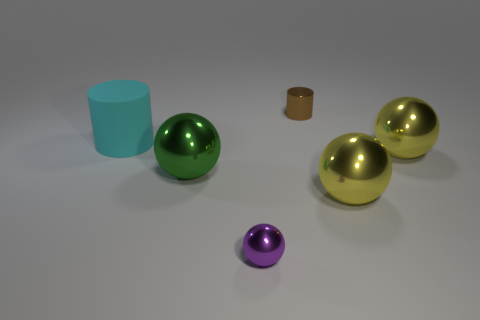Which object appears to be the largest? The largest object in the image appears to be the tall, light blue cylinder on the left side of the composition. Its height and overall size seem to exceed that of the other objects. 